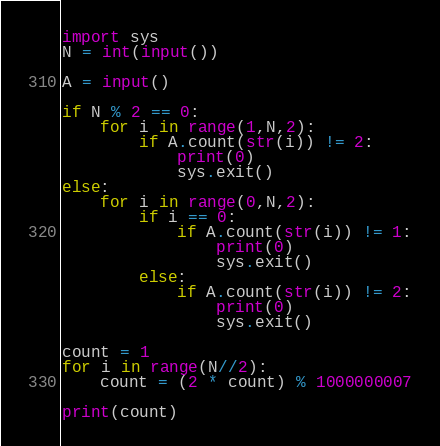Convert code to text. <code><loc_0><loc_0><loc_500><loc_500><_Python_>import sys
N = int(input())

A = input()

if N % 2 == 0:
    for i in range(1,N,2):
        if A.count(str(i)) != 2:
            print(0)
            sys.exit()
else:
    for i in range(0,N,2):
        if i == 0:
            if A.count(str(i)) != 1:
                print(0)
                sys.exit()
        else:
            if A.count(str(i)) != 2:
                print(0)
                sys.exit()

count = 1
for i in range(N//2):
    count = (2 * count) % 1000000007

print(count)
</code> 